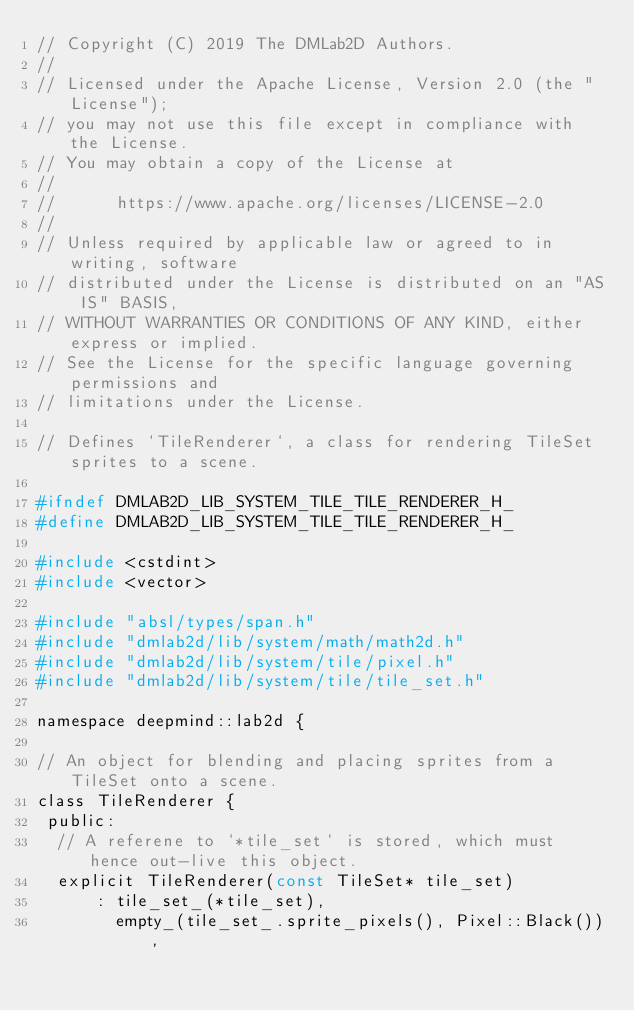<code> <loc_0><loc_0><loc_500><loc_500><_C_>// Copyright (C) 2019 The DMLab2D Authors.
//
// Licensed under the Apache License, Version 2.0 (the "License");
// you may not use this file except in compliance with the License.
// You may obtain a copy of the License at
//
//      https://www.apache.org/licenses/LICENSE-2.0
//
// Unless required by applicable law or agreed to in writing, software
// distributed under the License is distributed on an "AS IS" BASIS,
// WITHOUT WARRANTIES OR CONDITIONS OF ANY KIND, either express or implied.
// See the License for the specific language governing permissions and
// limitations under the License.

// Defines `TileRenderer`, a class for rendering TileSet sprites to a scene.

#ifndef DMLAB2D_LIB_SYSTEM_TILE_TILE_RENDERER_H_
#define DMLAB2D_LIB_SYSTEM_TILE_TILE_RENDERER_H_

#include <cstdint>
#include <vector>

#include "absl/types/span.h"
#include "dmlab2d/lib/system/math/math2d.h"
#include "dmlab2d/lib/system/tile/pixel.h"
#include "dmlab2d/lib/system/tile/tile_set.h"

namespace deepmind::lab2d {

// An object for blending and placing sprites from a TileSet onto a scene.
class TileRenderer {
 public:
  // A referene to `*tile_set` is stored, which must hence out-live this object.
  explicit TileRenderer(const TileSet* tile_set)
      : tile_set_(*tile_set),
        empty_(tile_set_.sprite_pixels(), Pixel::Black()),</code> 